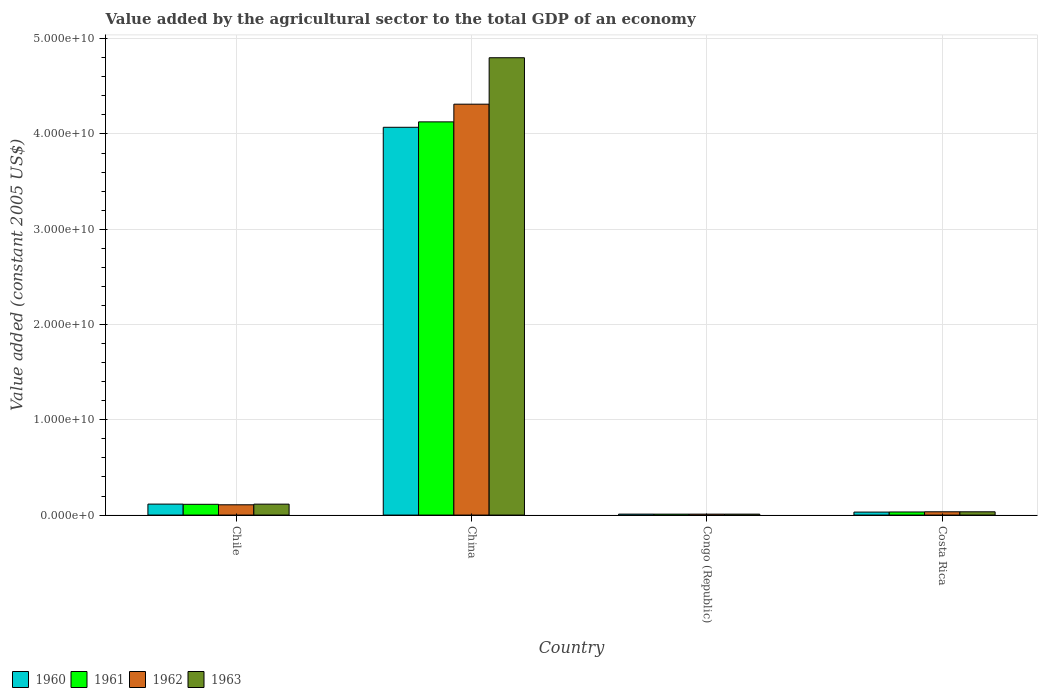How many different coloured bars are there?
Give a very brief answer. 4. Are the number of bars per tick equal to the number of legend labels?
Ensure brevity in your answer.  Yes. Are the number of bars on each tick of the X-axis equal?
Your response must be concise. Yes. How many bars are there on the 3rd tick from the right?
Offer a very short reply. 4. What is the label of the 2nd group of bars from the left?
Provide a short and direct response. China. What is the value added by the agricultural sector in 1962 in China?
Your answer should be very brief. 4.31e+1. Across all countries, what is the maximum value added by the agricultural sector in 1960?
Give a very brief answer. 4.07e+1. Across all countries, what is the minimum value added by the agricultural sector in 1963?
Offer a terse response. 9.86e+07. In which country was the value added by the agricultural sector in 1962 maximum?
Offer a terse response. China. In which country was the value added by the agricultural sector in 1961 minimum?
Your response must be concise. Congo (Republic). What is the total value added by the agricultural sector in 1962 in the graph?
Ensure brevity in your answer.  4.46e+1. What is the difference between the value added by the agricultural sector in 1962 in China and that in Congo (Republic)?
Ensure brevity in your answer.  4.30e+1. What is the difference between the value added by the agricultural sector in 1960 in China and the value added by the agricultural sector in 1961 in Congo (Republic)?
Provide a succinct answer. 4.06e+1. What is the average value added by the agricultural sector in 1962 per country?
Provide a short and direct response. 1.12e+1. What is the difference between the value added by the agricultural sector of/in 1962 and value added by the agricultural sector of/in 1960 in Costa Rica?
Your response must be concise. 3.14e+07. In how many countries, is the value added by the agricultural sector in 1962 greater than 12000000000 US$?
Your response must be concise. 1. What is the ratio of the value added by the agricultural sector in 1962 in Chile to that in China?
Ensure brevity in your answer.  0.03. What is the difference between the highest and the second highest value added by the agricultural sector in 1962?
Offer a very short reply. -4.28e+1. What is the difference between the highest and the lowest value added by the agricultural sector in 1963?
Offer a very short reply. 4.79e+1. In how many countries, is the value added by the agricultural sector in 1961 greater than the average value added by the agricultural sector in 1961 taken over all countries?
Make the answer very short. 1. Is it the case that in every country, the sum of the value added by the agricultural sector in 1961 and value added by the agricultural sector in 1963 is greater than the sum of value added by the agricultural sector in 1960 and value added by the agricultural sector in 1962?
Your response must be concise. No. What does the 4th bar from the right in Chile represents?
Offer a terse response. 1960. Is it the case that in every country, the sum of the value added by the agricultural sector in 1962 and value added by the agricultural sector in 1960 is greater than the value added by the agricultural sector in 1963?
Ensure brevity in your answer.  Yes. How many bars are there?
Your answer should be very brief. 16. Are all the bars in the graph horizontal?
Give a very brief answer. No. How many countries are there in the graph?
Keep it short and to the point. 4. What is the difference between two consecutive major ticks on the Y-axis?
Keep it short and to the point. 1.00e+1. Does the graph contain any zero values?
Provide a short and direct response. No. Does the graph contain grids?
Offer a terse response. Yes. Where does the legend appear in the graph?
Keep it short and to the point. Bottom left. How are the legend labels stacked?
Your response must be concise. Horizontal. What is the title of the graph?
Keep it short and to the point. Value added by the agricultural sector to the total GDP of an economy. Does "1982" appear as one of the legend labels in the graph?
Ensure brevity in your answer.  No. What is the label or title of the Y-axis?
Your response must be concise. Value added (constant 2005 US$). What is the Value added (constant 2005 US$) of 1960 in Chile?
Your answer should be very brief. 1.15e+09. What is the Value added (constant 2005 US$) in 1961 in Chile?
Your response must be concise. 1.13e+09. What is the Value added (constant 2005 US$) in 1962 in Chile?
Your answer should be compact. 1.08e+09. What is the Value added (constant 2005 US$) of 1963 in Chile?
Your response must be concise. 1.15e+09. What is the Value added (constant 2005 US$) of 1960 in China?
Provide a succinct answer. 4.07e+1. What is the Value added (constant 2005 US$) of 1961 in China?
Keep it short and to the point. 4.13e+1. What is the Value added (constant 2005 US$) in 1962 in China?
Offer a very short reply. 4.31e+1. What is the Value added (constant 2005 US$) of 1963 in China?
Make the answer very short. 4.80e+1. What is the Value added (constant 2005 US$) of 1960 in Congo (Republic)?
Give a very brief answer. 1.01e+08. What is the Value added (constant 2005 US$) of 1961 in Congo (Republic)?
Make the answer very short. 9.74e+07. What is the Value added (constant 2005 US$) of 1962 in Congo (Republic)?
Ensure brevity in your answer.  9.79e+07. What is the Value added (constant 2005 US$) of 1963 in Congo (Republic)?
Your response must be concise. 9.86e+07. What is the Value added (constant 2005 US$) in 1960 in Costa Rica?
Provide a succinct answer. 3.13e+08. What is the Value added (constant 2005 US$) of 1961 in Costa Rica?
Give a very brief answer. 3.24e+08. What is the Value added (constant 2005 US$) of 1962 in Costa Rica?
Provide a short and direct response. 3.44e+08. What is the Value added (constant 2005 US$) of 1963 in Costa Rica?
Give a very brief answer. 3.43e+08. Across all countries, what is the maximum Value added (constant 2005 US$) of 1960?
Ensure brevity in your answer.  4.07e+1. Across all countries, what is the maximum Value added (constant 2005 US$) in 1961?
Keep it short and to the point. 4.13e+1. Across all countries, what is the maximum Value added (constant 2005 US$) of 1962?
Offer a terse response. 4.31e+1. Across all countries, what is the maximum Value added (constant 2005 US$) in 1963?
Ensure brevity in your answer.  4.80e+1. Across all countries, what is the minimum Value added (constant 2005 US$) in 1960?
Keep it short and to the point. 1.01e+08. Across all countries, what is the minimum Value added (constant 2005 US$) in 1961?
Your answer should be compact. 9.74e+07. Across all countries, what is the minimum Value added (constant 2005 US$) of 1962?
Keep it short and to the point. 9.79e+07. Across all countries, what is the minimum Value added (constant 2005 US$) in 1963?
Keep it short and to the point. 9.86e+07. What is the total Value added (constant 2005 US$) in 1960 in the graph?
Offer a very short reply. 4.23e+1. What is the total Value added (constant 2005 US$) of 1961 in the graph?
Ensure brevity in your answer.  4.28e+1. What is the total Value added (constant 2005 US$) in 1962 in the graph?
Your response must be concise. 4.46e+1. What is the total Value added (constant 2005 US$) of 1963 in the graph?
Your answer should be very brief. 4.96e+1. What is the difference between the Value added (constant 2005 US$) of 1960 in Chile and that in China?
Your answer should be compact. -3.95e+1. What is the difference between the Value added (constant 2005 US$) of 1961 in Chile and that in China?
Your answer should be very brief. -4.01e+1. What is the difference between the Value added (constant 2005 US$) in 1962 in Chile and that in China?
Provide a short and direct response. -4.20e+1. What is the difference between the Value added (constant 2005 US$) in 1963 in Chile and that in China?
Keep it short and to the point. -4.69e+1. What is the difference between the Value added (constant 2005 US$) of 1960 in Chile and that in Congo (Republic)?
Offer a terse response. 1.05e+09. What is the difference between the Value added (constant 2005 US$) of 1961 in Chile and that in Congo (Republic)?
Offer a terse response. 1.03e+09. What is the difference between the Value added (constant 2005 US$) of 1962 in Chile and that in Congo (Republic)?
Your response must be concise. 9.81e+08. What is the difference between the Value added (constant 2005 US$) in 1963 in Chile and that in Congo (Republic)?
Your response must be concise. 1.05e+09. What is the difference between the Value added (constant 2005 US$) of 1960 in Chile and that in Costa Rica?
Ensure brevity in your answer.  8.39e+08. What is the difference between the Value added (constant 2005 US$) of 1961 in Chile and that in Costa Rica?
Make the answer very short. 8.06e+08. What is the difference between the Value added (constant 2005 US$) of 1962 in Chile and that in Costa Rica?
Your response must be concise. 7.35e+08. What is the difference between the Value added (constant 2005 US$) in 1963 in Chile and that in Costa Rica?
Provide a succinct answer. 8.03e+08. What is the difference between the Value added (constant 2005 US$) in 1960 in China and that in Congo (Republic)?
Make the answer very short. 4.06e+1. What is the difference between the Value added (constant 2005 US$) of 1961 in China and that in Congo (Republic)?
Provide a succinct answer. 4.12e+1. What is the difference between the Value added (constant 2005 US$) of 1962 in China and that in Congo (Republic)?
Ensure brevity in your answer.  4.30e+1. What is the difference between the Value added (constant 2005 US$) in 1963 in China and that in Congo (Republic)?
Offer a very short reply. 4.79e+1. What is the difference between the Value added (constant 2005 US$) in 1960 in China and that in Costa Rica?
Keep it short and to the point. 4.04e+1. What is the difference between the Value added (constant 2005 US$) of 1961 in China and that in Costa Rica?
Provide a succinct answer. 4.09e+1. What is the difference between the Value added (constant 2005 US$) of 1962 in China and that in Costa Rica?
Your answer should be very brief. 4.28e+1. What is the difference between the Value added (constant 2005 US$) in 1963 in China and that in Costa Rica?
Make the answer very short. 4.77e+1. What is the difference between the Value added (constant 2005 US$) of 1960 in Congo (Republic) and that in Costa Rica?
Make the answer very short. -2.12e+08. What is the difference between the Value added (constant 2005 US$) of 1961 in Congo (Republic) and that in Costa Rica?
Your answer should be very brief. -2.27e+08. What is the difference between the Value added (constant 2005 US$) of 1962 in Congo (Republic) and that in Costa Rica?
Offer a very short reply. -2.46e+08. What is the difference between the Value added (constant 2005 US$) of 1963 in Congo (Republic) and that in Costa Rica?
Your answer should be compact. -2.45e+08. What is the difference between the Value added (constant 2005 US$) of 1960 in Chile and the Value added (constant 2005 US$) of 1961 in China?
Offer a terse response. -4.01e+1. What is the difference between the Value added (constant 2005 US$) of 1960 in Chile and the Value added (constant 2005 US$) of 1962 in China?
Give a very brief answer. -4.20e+1. What is the difference between the Value added (constant 2005 US$) of 1960 in Chile and the Value added (constant 2005 US$) of 1963 in China?
Give a very brief answer. -4.68e+1. What is the difference between the Value added (constant 2005 US$) in 1961 in Chile and the Value added (constant 2005 US$) in 1962 in China?
Offer a terse response. -4.20e+1. What is the difference between the Value added (constant 2005 US$) of 1961 in Chile and the Value added (constant 2005 US$) of 1963 in China?
Your answer should be very brief. -4.69e+1. What is the difference between the Value added (constant 2005 US$) of 1962 in Chile and the Value added (constant 2005 US$) of 1963 in China?
Give a very brief answer. -4.69e+1. What is the difference between the Value added (constant 2005 US$) in 1960 in Chile and the Value added (constant 2005 US$) in 1961 in Congo (Republic)?
Keep it short and to the point. 1.05e+09. What is the difference between the Value added (constant 2005 US$) in 1960 in Chile and the Value added (constant 2005 US$) in 1962 in Congo (Republic)?
Your answer should be compact. 1.05e+09. What is the difference between the Value added (constant 2005 US$) of 1960 in Chile and the Value added (constant 2005 US$) of 1963 in Congo (Republic)?
Offer a terse response. 1.05e+09. What is the difference between the Value added (constant 2005 US$) in 1961 in Chile and the Value added (constant 2005 US$) in 1962 in Congo (Republic)?
Offer a very short reply. 1.03e+09. What is the difference between the Value added (constant 2005 US$) of 1961 in Chile and the Value added (constant 2005 US$) of 1963 in Congo (Republic)?
Offer a terse response. 1.03e+09. What is the difference between the Value added (constant 2005 US$) in 1962 in Chile and the Value added (constant 2005 US$) in 1963 in Congo (Republic)?
Offer a terse response. 9.81e+08. What is the difference between the Value added (constant 2005 US$) in 1960 in Chile and the Value added (constant 2005 US$) in 1961 in Costa Rica?
Your response must be concise. 8.27e+08. What is the difference between the Value added (constant 2005 US$) in 1960 in Chile and the Value added (constant 2005 US$) in 1962 in Costa Rica?
Your response must be concise. 8.07e+08. What is the difference between the Value added (constant 2005 US$) of 1960 in Chile and the Value added (constant 2005 US$) of 1963 in Costa Rica?
Your answer should be very brief. 8.08e+08. What is the difference between the Value added (constant 2005 US$) of 1961 in Chile and the Value added (constant 2005 US$) of 1962 in Costa Rica?
Ensure brevity in your answer.  7.86e+08. What is the difference between the Value added (constant 2005 US$) in 1961 in Chile and the Value added (constant 2005 US$) in 1963 in Costa Rica?
Make the answer very short. 7.87e+08. What is the difference between the Value added (constant 2005 US$) in 1962 in Chile and the Value added (constant 2005 US$) in 1963 in Costa Rica?
Offer a very short reply. 7.36e+08. What is the difference between the Value added (constant 2005 US$) of 1960 in China and the Value added (constant 2005 US$) of 1961 in Congo (Republic)?
Offer a terse response. 4.06e+1. What is the difference between the Value added (constant 2005 US$) of 1960 in China and the Value added (constant 2005 US$) of 1962 in Congo (Republic)?
Your answer should be very brief. 4.06e+1. What is the difference between the Value added (constant 2005 US$) in 1960 in China and the Value added (constant 2005 US$) in 1963 in Congo (Republic)?
Offer a very short reply. 4.06e+1. What is the difference between the Value added (constant 2005 US$) in 1961 in China and the Value added (constant 2005 US$) in 1962 in Congo (Republic)?
Offer a terse response. 4.12e+1. What is the difference between the Value added (constant 2005 US$) in 1961 in China and the Value added (constant 2005 US$) in 1963 in Congo (Republic)?
Ensure brevity in your answer.  4.12e+1. What is the difference between the Value added (constant 2005 US$) of 1962 in China and the Value added (constant 2005 US$) of 1963 in Congo (Republic)?
Offer a terse response. 4.30e+1. What is the difference between the Value added (constant 2005 US$) in 1960 in China and the Value added (constant 2005 US$) in 1961 in Costa Rica?
Provide a succinct answer. 4.04e+1. What is the difference between the Value added (constant 2005 US$) in 1960 in China and the Value added (constant 2005 US$) in 1962 in Costa Rica?
Provide a short and direct response. 4.04e+1. What is the difference between the Value added (constant 2005 US$) of 1960 in China and the Value added (constant 2005 US$) of 1963 in Costa Rica?
Your response must be concise. 4.04e+1. What is the difference between the Value added (constant 2005 US$) of 1961 in China and the Value added (constant 2005 US$) of 1962 in Costa Rica?
Keep it short and to the point. 4.09e+1. What is the difference between the Value added (constant 2005 US$) of 1961 in China and the Value added (constant 2005 US$) of 1963 in Costa Rica?
Offer a terse response. 4.09e+1. What is the difference between the Value added (constant 2005 US$) of 1962 in China and the Value added (constant 2005 US$) of 1963 in Costa Rica?
Provide a short and direct response. 4.28e+1. What is the difference between the Value added (constant 2005 US$) in 1960 in Congo (Republic) and the Value added (constant 2005 US$) in 1961 in Costa Rica?
Give a very brief answer. -2.24e+08. What is the difference between the Value added (constant 2005 US$) of 1960 in Congo (Republic) and the Value added (constant 2005 US$) of 1962 in Costa Rica?
Your response must be concise. -2.43e+08. What is the difference between the Value added (constant 2005 US$) in 1960 in Congo (Republic) and the Value added (constant 2005 US$) in 1963 in Costa Rica?
Provide a succinct answer. -2.42e+08. What is the difference between the Value added (constant 2005 US$) of 1961 in Congo (Republic) and the Value added (constant 2005 US$) of 1962 in Costa Rica?
Ensure brevity in your answer.  -2.47e+08. What is the difference between the Value added (constant 2005 US$) in 1961 in Congo (Republic) and the Value added (constant 2005 US$) in 1963 in Costa Rica?
Make the answer very short. -2.46e+08. What is the difference between the Value added (constant 2005 US$) of 1962 in Congo (Republic) and the Value added (constant 2005 US$) of 1963 in Costa Rica?
Provide a short and direct response. -2.45e+08. What is the average Value added (constant 2005 US$) in 1960 per country?
Provide a succinct answer. 1.06e+1. What is the average Value added (constant 2005 US$) of 1961 per country?
Your answer should be compact. 1.07e+1. What is the average Value added (constant 2005 US$) of 1962 per country?
Make the answer very short. 1.12e+1. What is the average Value added (constant 2005 US$) in 1963 per country?
Your response must be concise. 1.24e+1. What is the difference between the Value added (constant 2005 US$) of 1960 and Value added (constant 2005 US$) of 1961 in Chile?
Your response must be concise. 2.12e+07. What is the difference between the Value added (constant 2005 US$) of 1960 and Value added (constant 2005 US$) of 1962 in Chile?
Your answer should be compact. 7.27e+07. What is the difference between the Value added (constant 2005 US$) in 1960 and Value added (constant 2005 US$) in 1963 in Chile?
Your response must be concise. 5.74e+06. What is the difference between the Value added (constant 2005 US$) of 1961 and Value added (constant 2005 US$) of 1962 in Chile?
Offer a very short reply. 5.15e+07. What is the difference between the Value added (constant 2005 US$) in 1961 and Value added (constant 2005 US$) in 1963 in Chile?
Offer a terse response. -1.54e+07. What is the difference between the Value added (constant 2005 US$) in 1962 and Value added (constant 2005 US$) in 1963 in Chile?
Make the answer very short. -6.69e+07. What is the difference between the Value added (constant 2005 US$) of 1960 and Value added (constant 2005 US$) of 1961 in China?
Your response must be concise. -5.70e+08. What is the difference between the Value added (constant 2005 US$) of 1960 and Value added (constant 2005 US$) of 1962 in China?
Provide a succinct answer. -2.43e+09. What is the difference between the Value added (constant 2005 US$) of 1960 and Value added (constant 2005 US$) of 1963 in China?
Offer a terse response. -7.30e+09. What is the difference between the Value added (constant 2005 US$) in 1961 and Value added (constant 2005 US$) in 1962 in China?
Keep it short and to the point. -1.86e+09. What is the difference between the Value added (constant 2005 US$) of 1961 and Value added (constant 2005 US$) of 1963 in China?
Provide a short and direct response. -6.73e+09. What is the difference between the Value added (constant 2005 US$) of 1962 and Value added (constant 2005 US$) of 1963 in China?
Your answer should be very brief. -4.87e+09. What is the difference between the Value added (constant 2005 US$) in 1960 and Value added (constant 2005 US$) in 1961 in Congo (Republic)?
Offer a very short reply. 3.61e+06. What is the difference between the Value added (constant 2005 US$) of 1960 and Value added (constant 2005 US$) of 1962 in Congo (Republic)?
Your response must be concise. 3.02e+06. What is the difference between the Value added (constant 2005 US$) in 1960 and Value added (constant 2005 US$) in 1963 in Congo (Republic)?
Your answer should be very brief. 2.34e+06. What is the difference between the Value added (constant 2005 US$) of 1961 and Value added (constant 2005 US$) of 1962 in Congo (Republic)?
Your answer should be compact. -5.86e+05. What is the difference between the Value added (constant 2005 US$) of 1961 and Value added (constant 2005 US$) of 1963 in Congo (Republic)?
Your answer should be very brief. -1.27e+06. What is the difference between the Value added (constant 2005 US$) of 1962 and Value added (constant 2005 US$) of 1963 in Congo (Republic)?
Ensure brevity in your answer.  -6.85e+05. What is the difference between the Value added (constant 2005 US$) of 1960 and Value added (constant 2005 US$) of 1961 in Costa Rica?
Offer a terse response. -1.15e+07. What is the difference between the Value added (constant 2005 US$) of 1960 and Value added (constant 2005 US$) of 1962 in Costa Rica?
Your answer should be compact. -3.14e+07. What is the difference between the Value added (constant 2005 US$) in 1960 and Value added (constant 2005 US$) in 1963 in Costa Rica?
Your answer should be compact. -3.04e+07. What is the difference between the Value added (constant 2005 US$) in 1961 and Value added (constant 2005 US$) in 1962 in Costa Rica?
Give a very brief answer. -1.99e+07. What is the difference between the Value added (constant 2005 US$) of 1961 and Value added (constant 2005 US$) of 1963 in Costa Rica?
Your answer should be very brief. -1.89e+07. What is the difference between the Value added (constant 2005 US$) in 1962 and Value added (constant 2005 US$) in 1963 in Costa Rica?
Provide a short and direct response. 1.00e+06. What is the ratio of the Value added (constant 2005 US$) in 1960 in Chile to that in China?
Provide a succinct answer. 0.03. What is the ratio of the Value added (constant 2005 US$) in 1961 in Chile to that in China?
Provide a succinct answer. 0.03. What is the ratio of the Value added (constant 2005 US$) of 1962 in Chile to that in China?
Your response must be concise. 0.03. What is the ratio of the Value added (constant 2005 US$) in 1963 in Chile to that in China?
Keep it short and to the point. 0.02. What is the ratio of the Value added (constant 2005 US$) in 1960 in Chile to that in Congo (Republic)?
Ensure brevity in your answer.  11.41. What is the ratio of the Value added (constant 2005 US$) in 1961 in Chile to that in Congo (Republic)?
Offer a terse response. 11.61. What is the ratio of the Value added (constant 2005 US$) in 1962 in Chile to that in Congo (Republic)?
Keep it short and to the point. 11.02. What is the ratio of the Value added (constant 2005 US$) of 1963 in Chile to that in Congo (Republic)?
Your answer should be compact. 11.62. What is the ratio of the Value added (constant 2005 US$) of 1960 in Chile to that in Costa Rica?
Your answer should be very brief. 3.68. What is the ratio of the Value added (constant 2005 US$) in 1961 in Chile to that in Costa Rica?
Provide a succinct answer. 3.48. What is the ratio of the Value added (constant 2005 US$) in 1962 in Chile to that in Costa Rica?
Offer a terse response. 3.13. What is the ratio of the Value added (constant 2005 US$) of 1963 in Chile to that in Costa Rica?
Offer a very short reply. 3.34. What is the ratio of the Value added (constant 2005 US$) of 1960 in China to that in Congo (Republic)?
Ensure brevity in your answer.  403.12. What is the ratio of the Value added (constant 2005 US$) of 1961 in China to that in Congo (Republic)?
Ensure brevity in your answer.  423.9. What is the ratio of the Value added (constant 2005 US$) of 1962 in China to that in Congo (Republic)?
Offer a terse response. 440.32. What is the ratio of the Value added (constant 2005 US$) in 1963 in China to that in Congo (Republic)?
Provide a short and direct response. 486.68. What is the ratio of the Value added (constant 2005 US$) in 1960 in China to that in Costa Rica?
Ensure brevity in your answer.  130.03. What is the ratio of the Value added (constant 2005 US$) of 1961 in China to that in Costa Rica?
Provide a short and direct response. 127.18. What is the ratio of the Value added (constant 2005 US$) of 1962 in China to that in Costa Rica?
Keep it short and to the point. 125.23. What is the ratio of the Value added (constant 2005 US$) of 1963 in China to that in Costa Rica?
Provide a succinct answer. 139.78. What is the ratio of the Value added (constant 2005 US$) in 1960 in Congo (Republic) to that in Costa Rica?
Make the answer very short. 0.32. What is the ratio of the Value added (constant 2005 US$) in 1961 in Congo (Republic) to that in Costa Rica?
Offer a terse response. 0.3. What is the ratio of the Value added (constant 2005 US$) of 1962 in Congo (Republic) to that in Costa Rica?
Provide a succinct answer. 0.28. What is the ratio of the Value added (constant 2005 US$) in 1963 in Congo (Republic) to that in Costa Rica?
Keep it short and to the point. 0.29. What is the difference between the highest and the second highest Value added (constant 2005 US$) of 1960?
Keep it short and to the point. 3.95e+1. What is the difference between the highest and the second highest Value added (constant 2005 US$) of 1961?
Provide a succinct answer. 4.01e+1. What is the difference between the highest and the second highest Value added (constant 2005 US$) in 1962?
Provide a succinct answer. 4.20e+1. What is the difference between the highest and the second highest Value added (constant 2005 US$) in 1963?
Your answer should be very brief. 4.69e+1. What is the difference between the highest and the lowest Value added (constant 2005 US$) in 1960?
Your response must be concise. 4.06e+1. What is the difference between the highest and the lowest Value added (constant 2005 US$) in 1961?
Keep it short and to the point. 4.12e+1. What is the difference between the highest and the lowest Value added (constant 2005 US$) of 1962?
Provide a short and direct response. 4.30e+1. What is the difference between the highest and the lowest Value added (constant 2005 US$) in 1963?
Provide a short and direct response. 4.79e+1. 